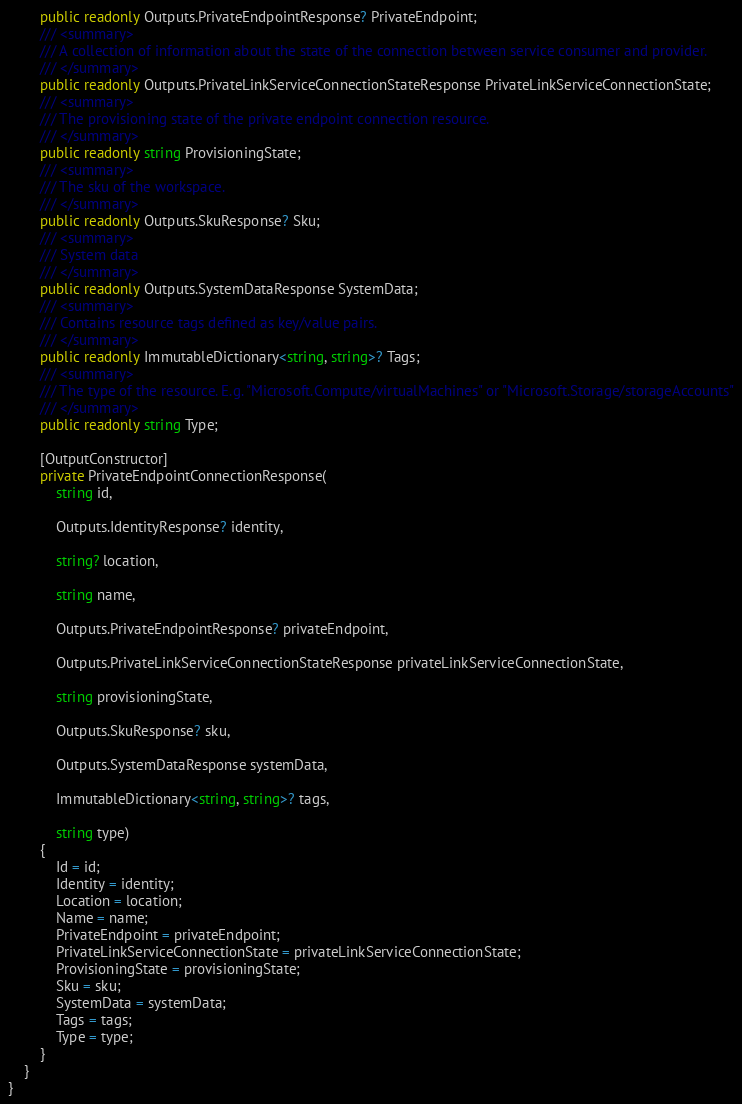<code> <loc_0><loc_0><loc_500><loc_500><_C#_>        public readonly Outputs.PrivateEndpointResponse? PrivateEndpoint;
        /// <summary>
        /// A collection of information about the state of the connection between service consumer and provider.
        /// </summary>
        public readonly Outputs.PrivateLinkServiceConnectionStateResponse PrivateLinkServiceConnectionState;
        /// <summary>
        /// The provisioning state of the private endpoint connection resource.
        /// </summary>
        public readonly string ProvisioningState;
        /// <summary>
        /// The sku of the workspace.
        /// </summary>
        public readonly Outputs.SkuResponse? Sku;
        /// <summary>
        /// System data
        /// </summary>
        public readonly Outputs.SystemDataResponse SystemData;
        /// <summary>
        /// Contains resource tags defined as key/value pairs.
        /// </summary>
        public readonly ImmutableDictionary<string, string>? Tags;
        /// <summary>
        /// The type of the resource. E.g. "Microsoft.Compute/virtualMachines" or "Microsoft.Storage/storageAccounts"
        /// </summary>
        public readonly string Type;

        [OutputConstructor]
        private PrivateEndpointConnectionResponse(
            string id,

            Outputs.IdentityResponse? identity,

            string? location,

            string name,

            Outputs.PrivateEndpointResponse? privateEndpoint,

            Outputs.PrivateLinkServiceConnectionStateResponse privateLinkServiceConnectionState,

            string provisioningState,

            Outputs.SkuResponse? sku,

            Outputs.SystemDataResponse systemData,

            ImmutableDictionary<string, string>? tags,

            string type)
        {
            Id = id;
            Identity = identity;
            Location = location;
            Name = name;
            PrivateEndpoint = privateEndpoint;
            PrivateLinkServiceConnectionState = privateLinkServiceConnectionState;
            ProvisioningState = provisioningState;
            Sku = sku;
            SystemData = systemData;
            Tags = tags;
            Type = type;
        }
    }
}
</code> 